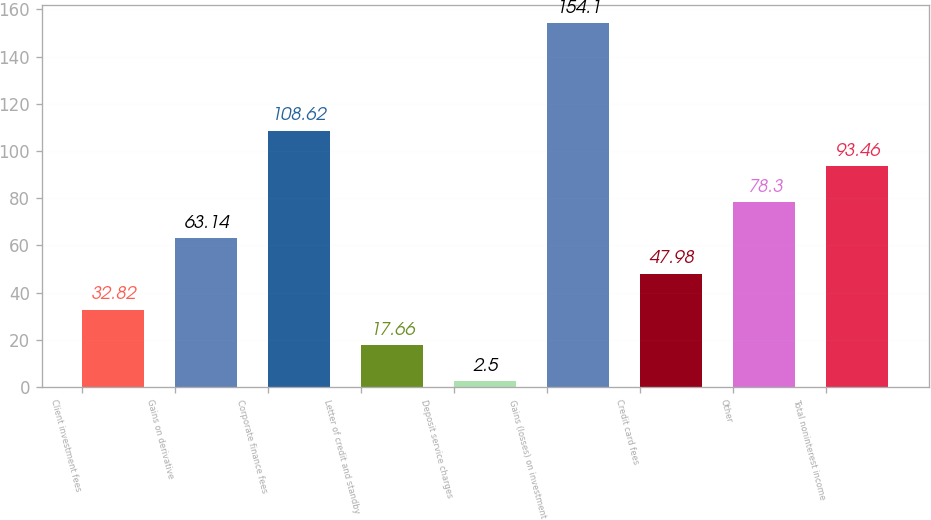Convert chart to OTSL. <chart><loc_0><loc_0><loc_500><loc_500><bar_chart><fcel>Client investment fees<fcel>Gains on derivative<fcel>Corporate finance fees<fcel>Letter of credit and standby<fcel>Deposit service charges<fcel>Gains (losses) on investment<fcel>Credit card fees<fcel>Other<fcel>Total noninterest income<nl><fcel>32.82<fcel>63.14<fcel>108.62<fcel>17.66<fcel>2.5<fcel>154.1<fcel>47.98<fcel>78.3<fcel>93.46<nl></chart> 